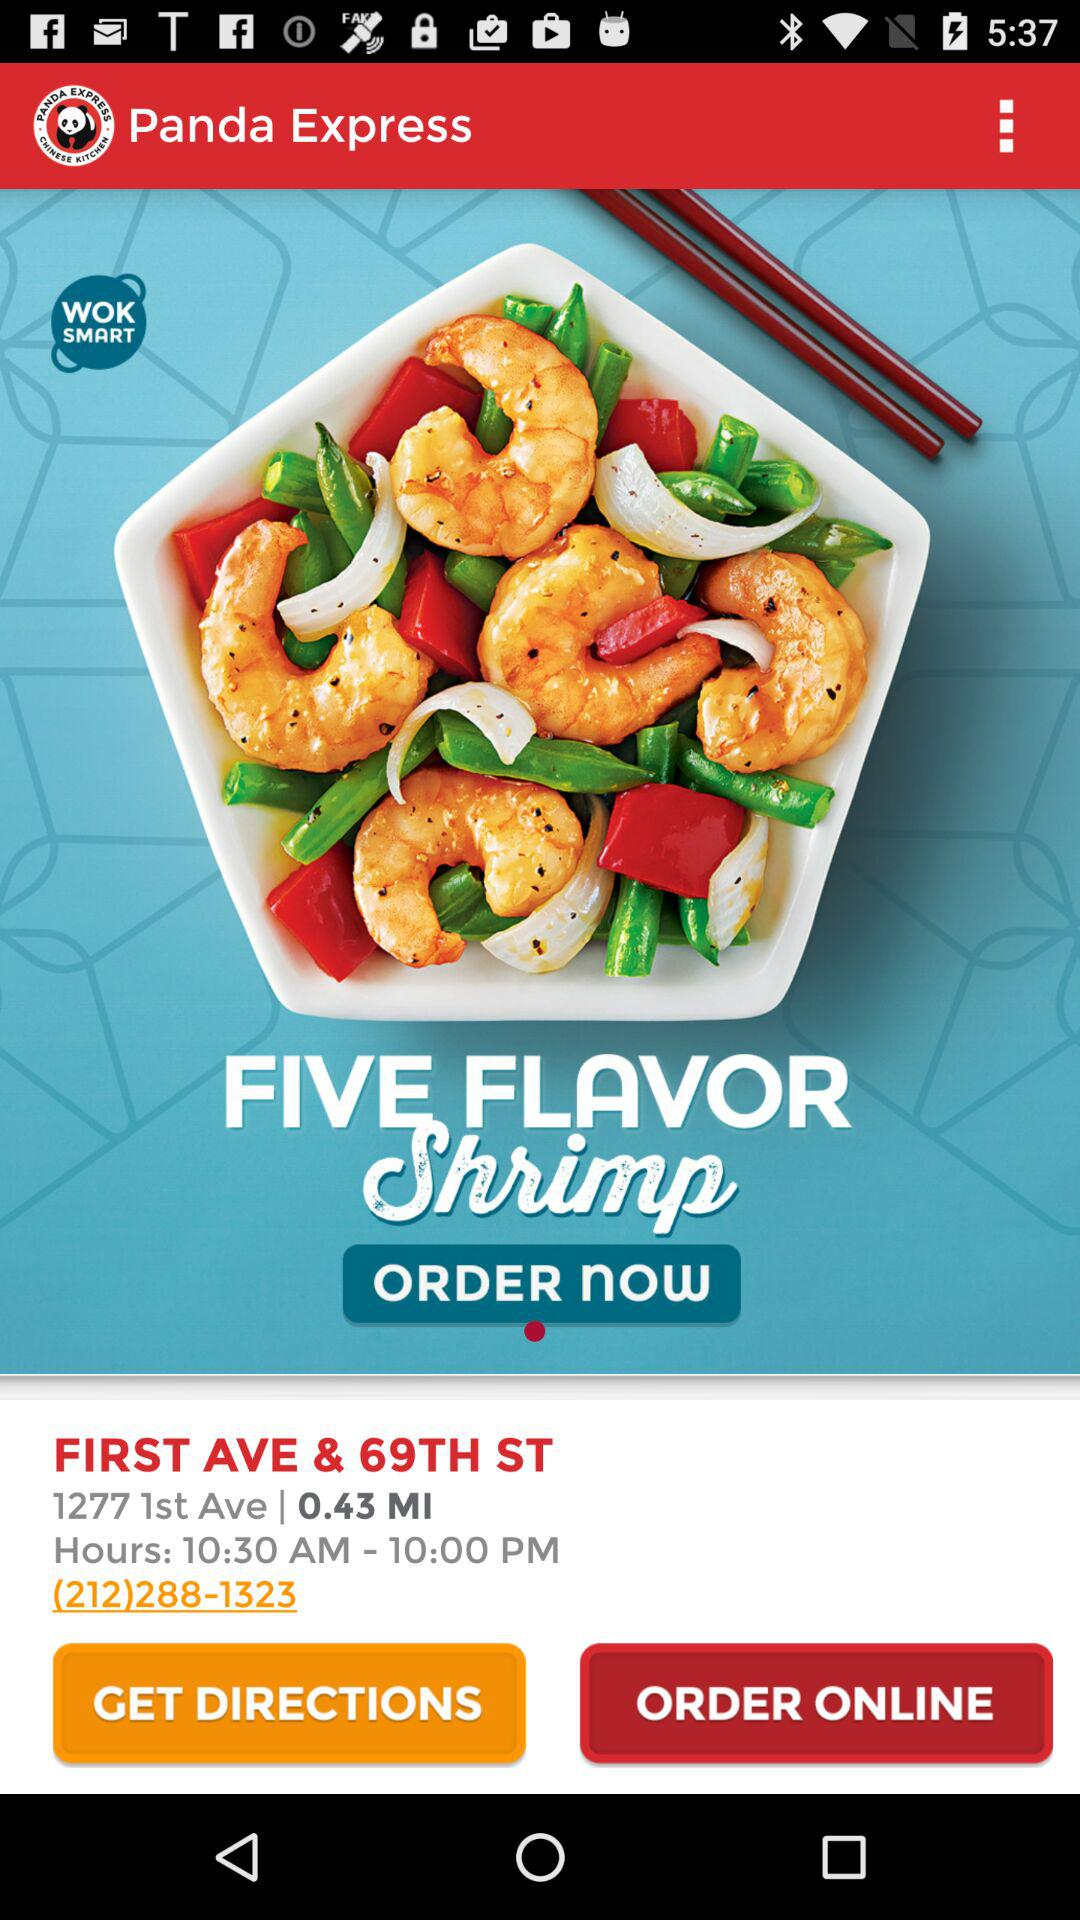What is the name of the application? The name of the application is "Panda Express". 